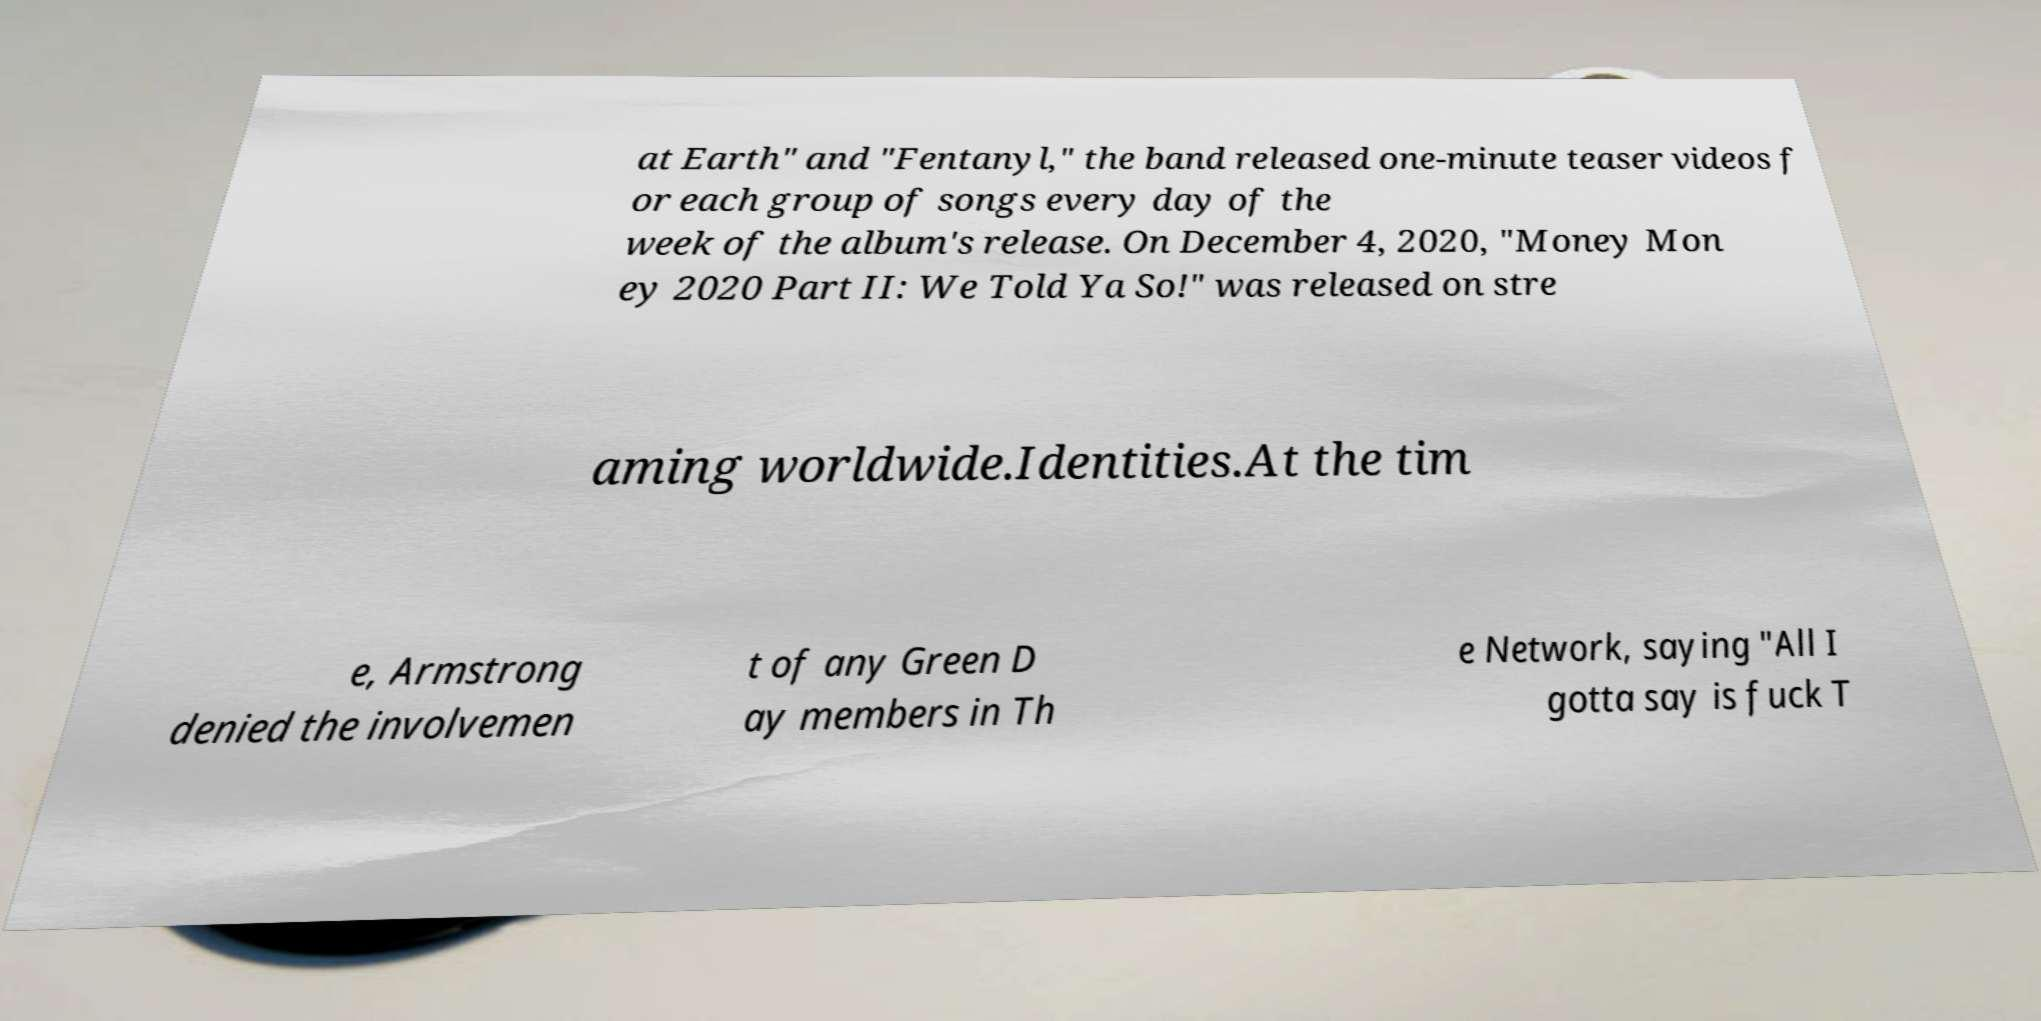Could you extract and type out the text from this image? at Earth" and "Fentanyl," the band released one-minute teaser videos f or each group of songs every day of the week of the album's release. On December 4, 2020, "Money Mon ey 2020 Part II: We Told Ya So!" was released on stre aming worldwide.Identities.At the tim e, Armstrong denied the involvemen t of any Green D ay members in Th e Network, saying "All I gotta say is fuck T 